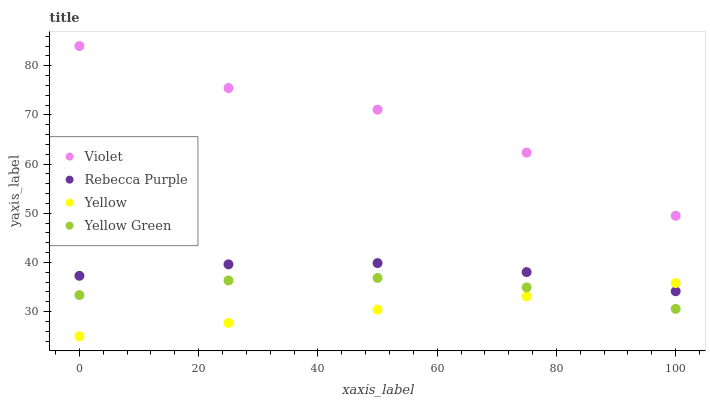Does Yellow have the minimum area under the curve?
Answer yes or no. Yes. Does Violet have the maximum area under the curve?
Answer yes or no. Yes. Does Rebecca Purple have the minimum area under the curve?
Answer yes or no. No. Does Rebecca Purple have the maximum area under the curve?
Answer yes or no. No. Is Yellow the smoothest?
Answer yes or no. Yes. Is Violet the roughest?
Answer yes or no. Yes. Is Rebecca Purple the smoothest?
Answer yes or no. No. Is Rebecca Purple the roughest?
Answer yes or no. No. Does Yellow have the lowest value?
Answer yes or no. Yes. Does Rebecca Purple have the lowest value?
Answer yes or no. No. Does Violet have the highest value?
Answer yes or no. Yes. Does Rebecca Purple have the highest value?
Answer yes or no. No. Is Yellow Green less than Rebecca Purple?
Answer yes or no. Yes. Is Violet greater than Yellow Green?
Answer yes or no. Yes. Does Yellow Green intersect Yellow?
Answer yes or no. Yes. Is Yellow Green less than Yellow?
Answer yes or no. No. Is Yellow Green greater than Yellow?
Answer yes or no. No. Does Yellow Green intersect Rebecca Purple?
Answer yes or no. No. 